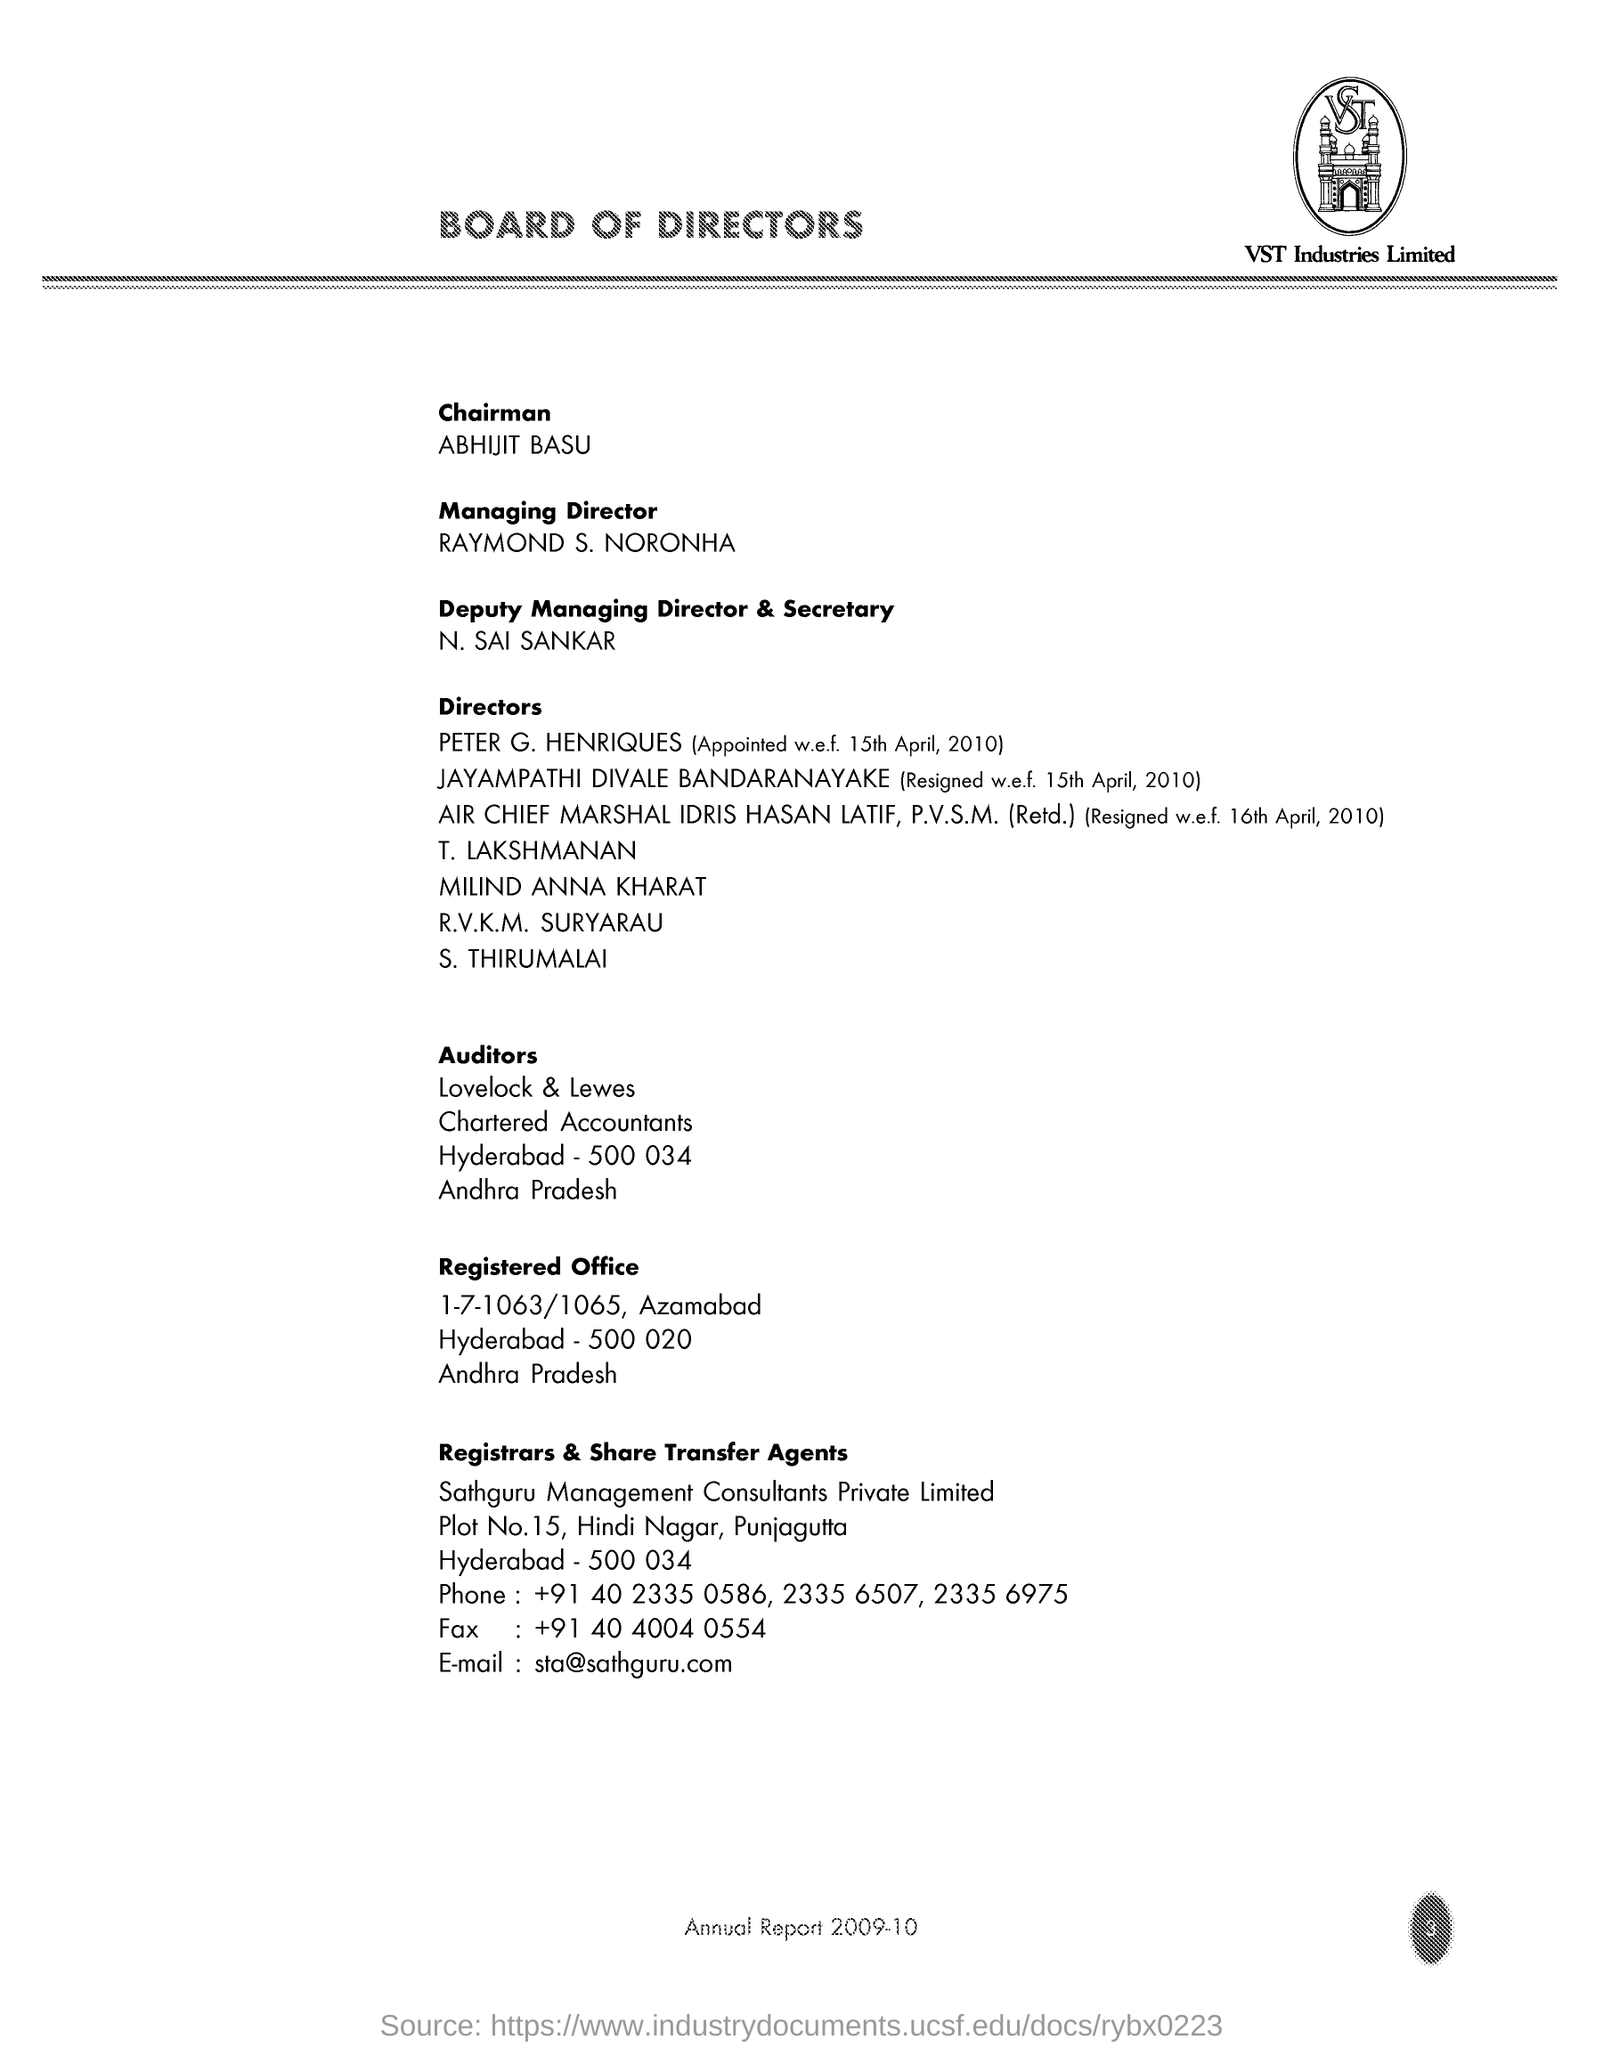Give some essential details in this illustration. The fax number is +91 40 4004 0554. The Chairman is Abhijit Basu. The company name is VST and is a [specific type of company]. The letterhead indicates that the letter was sent from the Board of Directors. The person named N. Sai Sankar is the Deputy Managing Director and Secretary. 